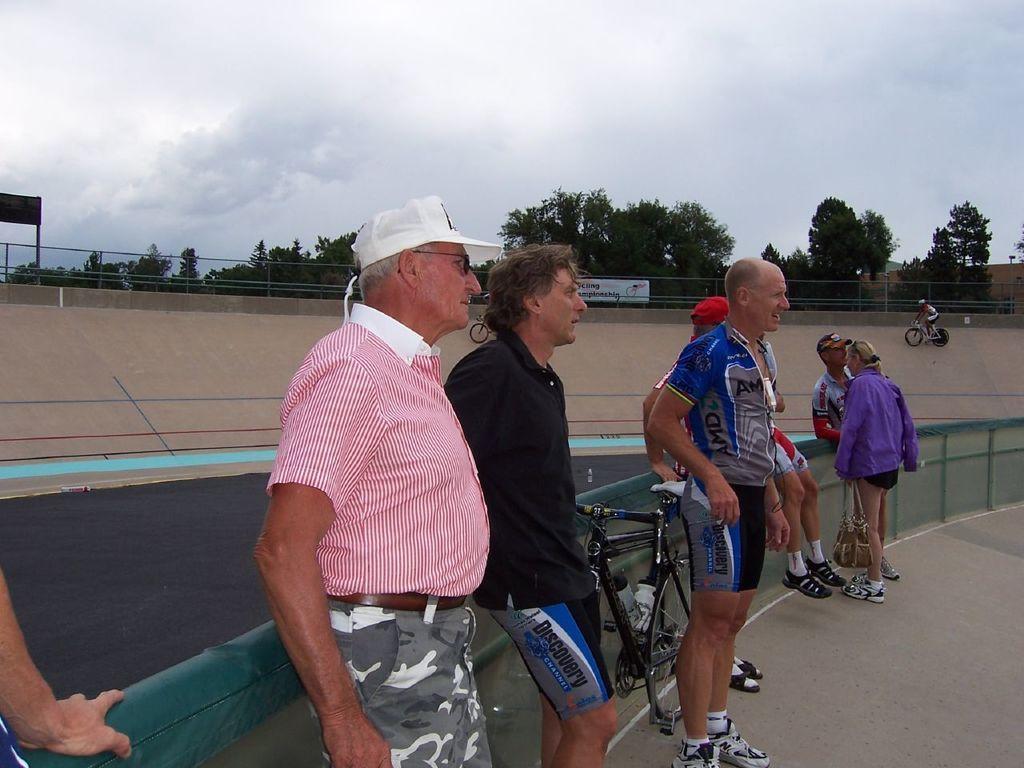Describe this image in one or two sentences. As we can see in the image there is a sky, trees, fence, ground and few people standing over here and there is a bicycle. 